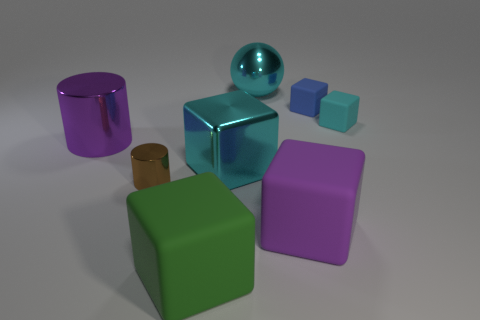There is a rubber thing on the left side of the big ball; is it the same color as the metallic ball? no 